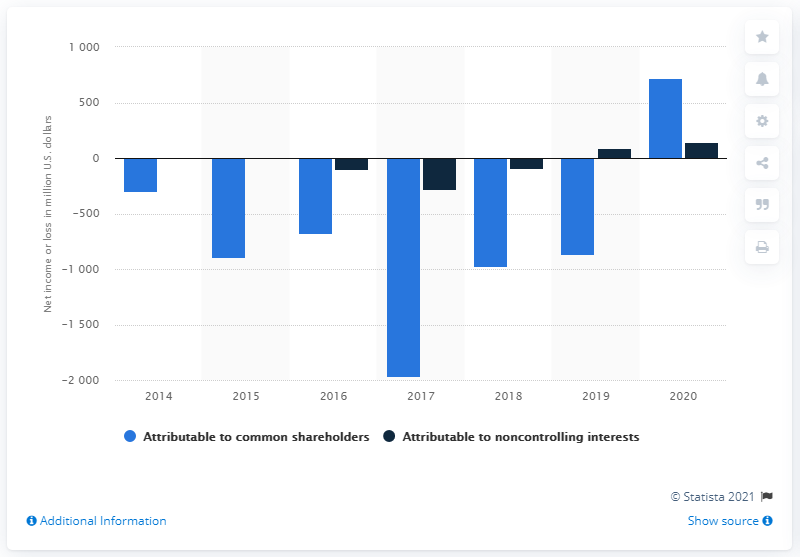Indicate a few pertinent items in this graphic. The net income attributable to Tesla's common stockholders was $721 million. Tesla achieved its first full-year profit on record in 2020. Tesla's noncontrolling interest net income for the year 2020 was approximately $141 million. 